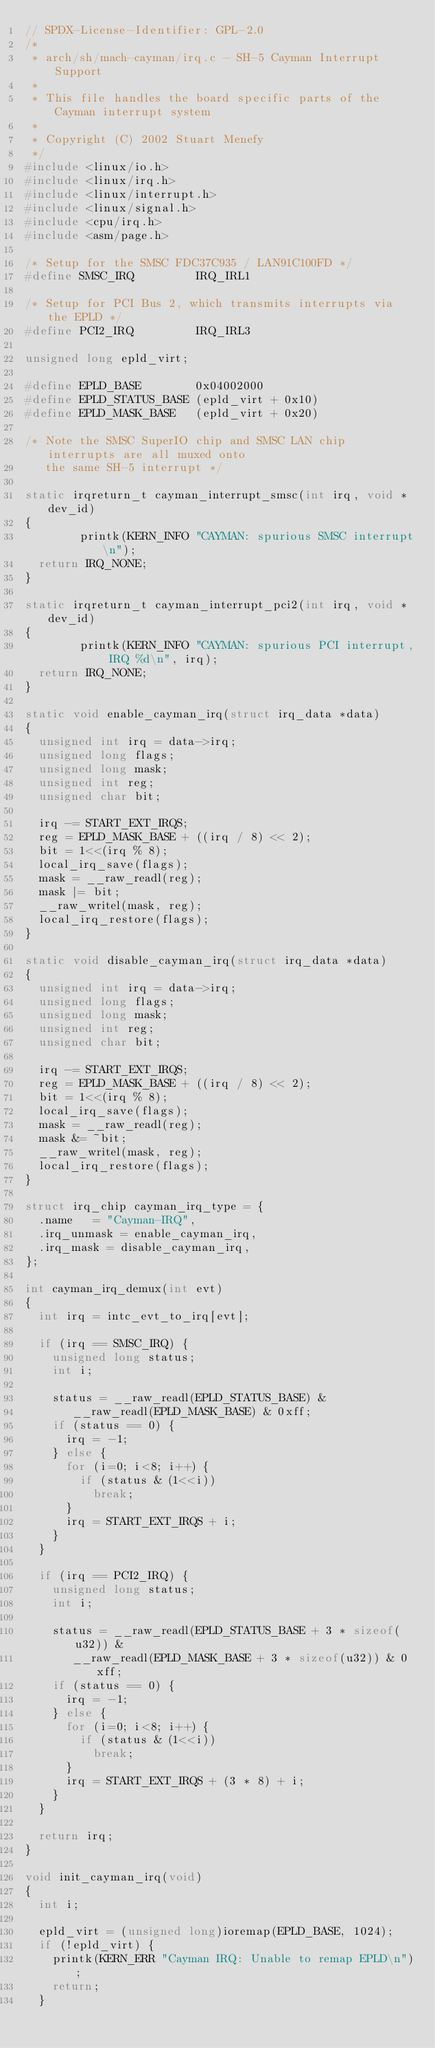Convert code to text. <code><loc_0><loc_0><loc_500><loc_500><_C_>// SPDX-License-Identifier: GPL-2.0
/*
 * arch/sh/mach-cayman/irq.c - SH-5 Cayman Interrupt Support
 *
 * This file handles the board specific parts of the Cayman interrupt system
 *
 * Copyright (C) 2002 Stuart Menefy
 */
#include <linux/io.h>
#include <linux/irq.h>
#include <linux/interrupt.h>
#include <linux/signal.h>
#include <cpu/irq.h>
#include <asm/page.h>

/* Setup for the SMSC FDC37C935 / LAN91C100FD */
#define SMSC_IRQ         IRQ_IRL1

/* Setup for PCI Bus 2, which transmits interrupts via the EPLD */
#define PCI2_IRQ         IRQ_IRL3

unsigned long epld_virt;

#define EPLD_BASE        0x04002000
#define EPLD_STATUS_BASE (epld_virt + 0x10)
#define EPLD_MASK_BASE   (epld_virt + 0x20)

/* Note the SMSC SuperIO chip and SMSC LAN chip interrupts are all muxed onto
   the same SH-5 interrupt */

static irqreturn_t cayman_interrupt_smsc(int irq, void *dev_id)
{
        printk(KERN_INFO "CAYMAN: spurious SMSC interrupt\n");
	return IRQ_NONE;
}

static irqreturn_t cayman_interrupt_pci2(int irq, void *dev_id)
{
        printk(KERN_INFO "CAYMAN: spurious PCI interrupt, IRQ %d\n", irq);
	return IRQ_NONE;
}

static void enable_cayman_irq(struct irq_data *data)
{
	unsigned int irq = data->irq;
	unsigned long flags;
	unsigned long mask;
	unsigned int reg;
	unsigned char bit;

	irq -= START_EXT_IRQS;
	reg = EPLD_MASK_BASE + ((irq / 8) << 2);
	bit = 1<<(irq % 8);
	local_irq_save(flags);
	mask = __raw_readl(reg);
	mask |= bit;
	__raw_writel(mask, reg);
	local_irq_restore(flags);
}

static void disable_cayman_irq(struct irq_data *data)
{
	unsigned int irq = data->irq;
	unsigned long flags;
	unsigned long mask;
	unsigned int reg;
	unsigned char bit;

	irq -= START_EXT_IRQS;
	reg = EPLD_MASK_BASE + ((irq / 8) << 2);
	bit = 1<<(irq % 8);
	local_irq_save(flags);
	mask = __raw_readl(reg);
	mask &= ~bit;
	__raw_writel(mask, reg);
	local_irq_restore(flags);
}

struct irq_chip cayman_irq_type = {
	.name		= "Cayman-IRQ",
	.irq_unmask	= enable_cayman_irq,
	.irq_mask	= disable_cayman_irq,
};

int cayman_irq_demux(int evt)
{
	int irq = intc_evt_to_irq[evt];

	if (irq == SMSC_IRQ) {
		unsigned long status;
		int i;

		status = __raw_readl(EPLD_STATUS_BASE) &
			 __raw_readl(EPLD_MASK_BASE) & 0xff;
		if (status == 0) {
			irq = -1;
		} else {
			for (i=0; i<8; i++) {
				if (status & (1<<i))
					break;
			}
			irq = START_EXT_IRQS + i;
		}
	}

	if (irq == PCI2_IRQ) {
		unsigned long status;
		int i;

		status = __raw_readl(EPLD_STATUS_BASE + 3 * sizeof(u32)) &
			 __raw_readl(EPLD_MASK_BASE + 3 * sizeof(u32)) & 0xff;
		if (status == 0) {
			irq = -1;
		} else {
			for (i=0; i<8; i++) {
				if (status & (1<<i))
					break;
			}
			irq = START_EXT_IRQS + (3 * 8) + i;
		}
	}

	return irq;
}

void init_cayman_irq(void)
{
	int i;

	epld_virt = (unsigned long)ioremap(EPLD_BASE, 1024);
	if (!epld_virt) {
		printk(KERN_ERR "Cayman IRQ: Unable to remap EPLD\n");
		return;
	}
</code> 